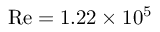<formula> <loc_0><loc_0><loc_500><loc_500>R e = 1 . 2 2 \times 1 0 ^ { 5 }</formula> 